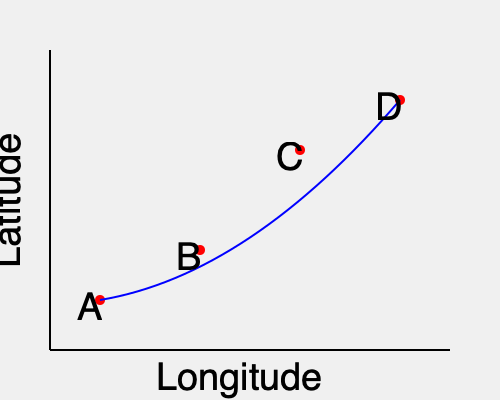Based on the GPS coordinates plotted on the map, calculate the average rate of latitudinal change per longitudinal degree for the bird's migration path from point A to point D. Express your answer in degrees latitude per degree longitude. To solve this problem, we'll follow these steps:

1. Identify the start and end points:
   Point A: (100, 300)
   Point D: (400, 100)

2. Calculate the total change in latitude:
   $\Delta \text{Latitude} = 300 - 100 = 200$ units

3. Calculate the total change in longitude:
   $\Delta \text{Longitude} = 400 - 100 = 300$ units

4. Convert the changes to degrees:
   Assuming the graph represents a 10° × 10° area:
   $\Delta \text{Latitude} = 200 \text{ units} \times \frac{10°}{300 \text{ units}} = \frac{20}{3}°$
   $\Delta \text{Longitude} = 300 \text{ units} \times \frac{10°}{400 \text{ units}} = \frac{15}{2}°$

5. Calculate the rate of latitudinal change per longitudinal degree:
   $\text{Rate} = \frac{\Delta \text{Latitude}}{\Delta \text{Longitude}} = \frac{20/3}{15/2} = \frac{20}{3} \times \frac{2}{15} = \frac{40}{45} = \frac{8}{9}$

Therefore, the average rate of latitudinal change is $\frac{8}{9}$ degrees latitude per degree longitude.
Answer: $\frac{8}{9}$ degrees latitude/degree longitude 